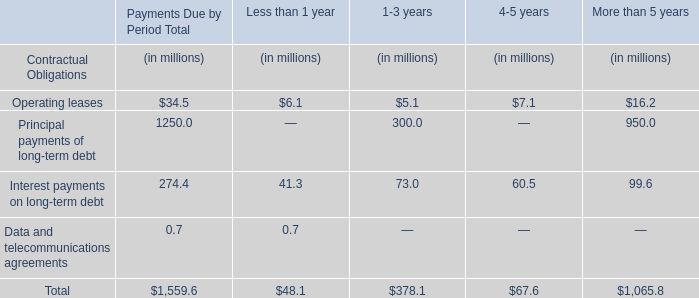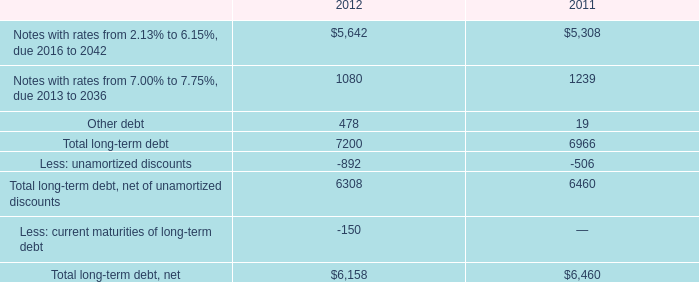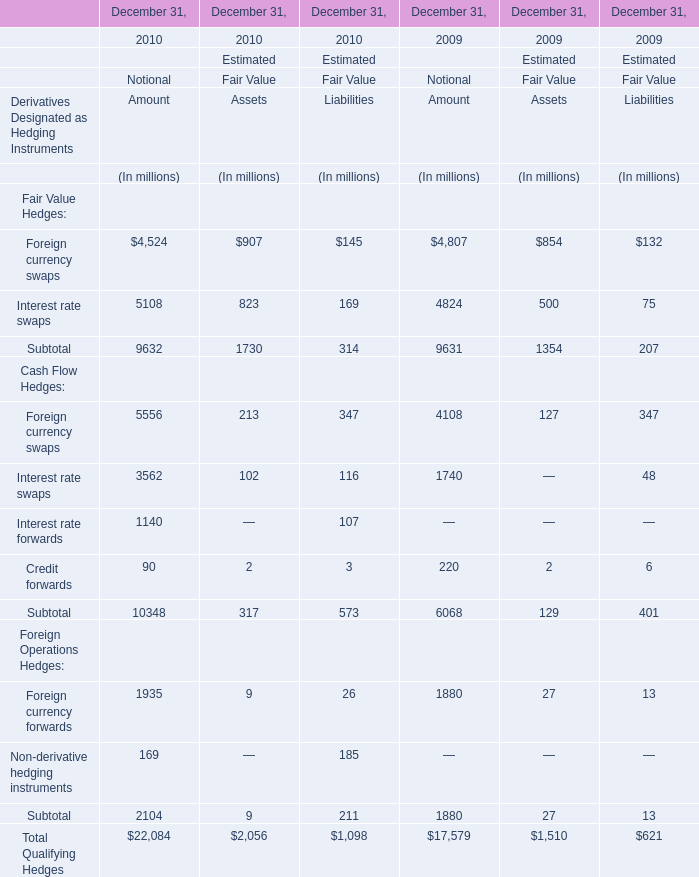If Interest rate swaps develops with the same growth rate in 2009, what will it reach in 2010 for amount? (in million) 
Computations: (5108 * (1 + ((5108 - 4824) / 4824)))
Answer: 5408.71973. 